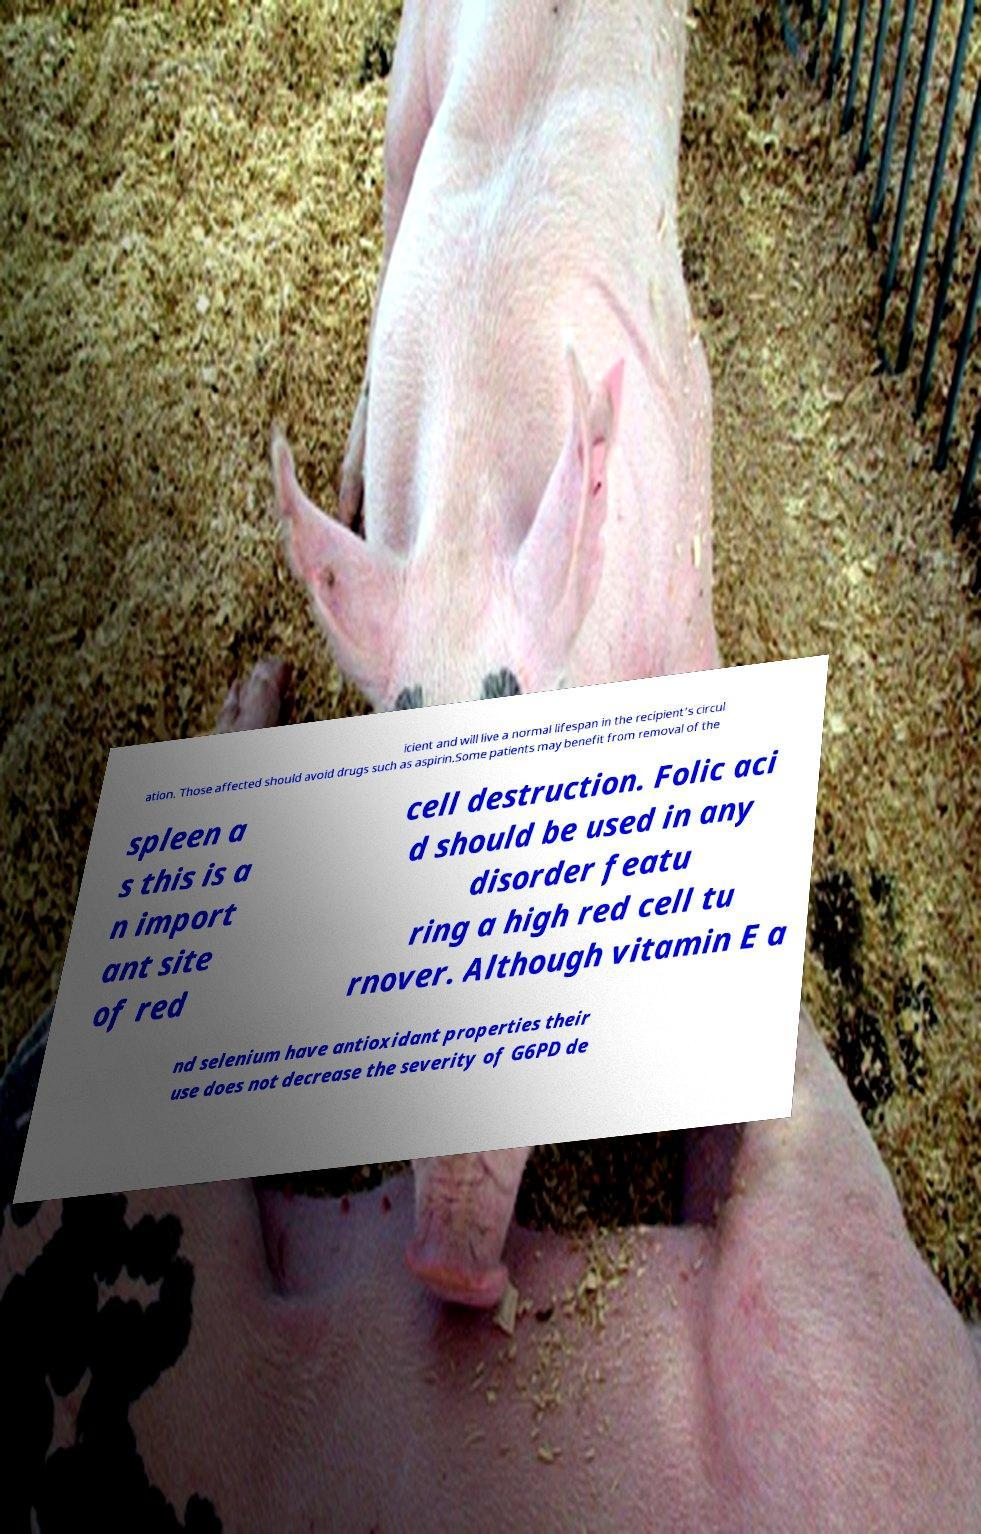For documentation purposes, I need the text within this image transcribed. Could you provide that? icient and will live a normal lifespan in the recipient's circul ation. Those affected should avoid drugs such as aspirin.Some patients may benefit from removal of the spleen a s this is a n import ant site of red cell destruction. Folic aci d should be used in any disorder featu ring a high red cell tu rnover. Although vitamin E a nd selenium have antioxidant properties their use does not decrease the severity of G6PD de 